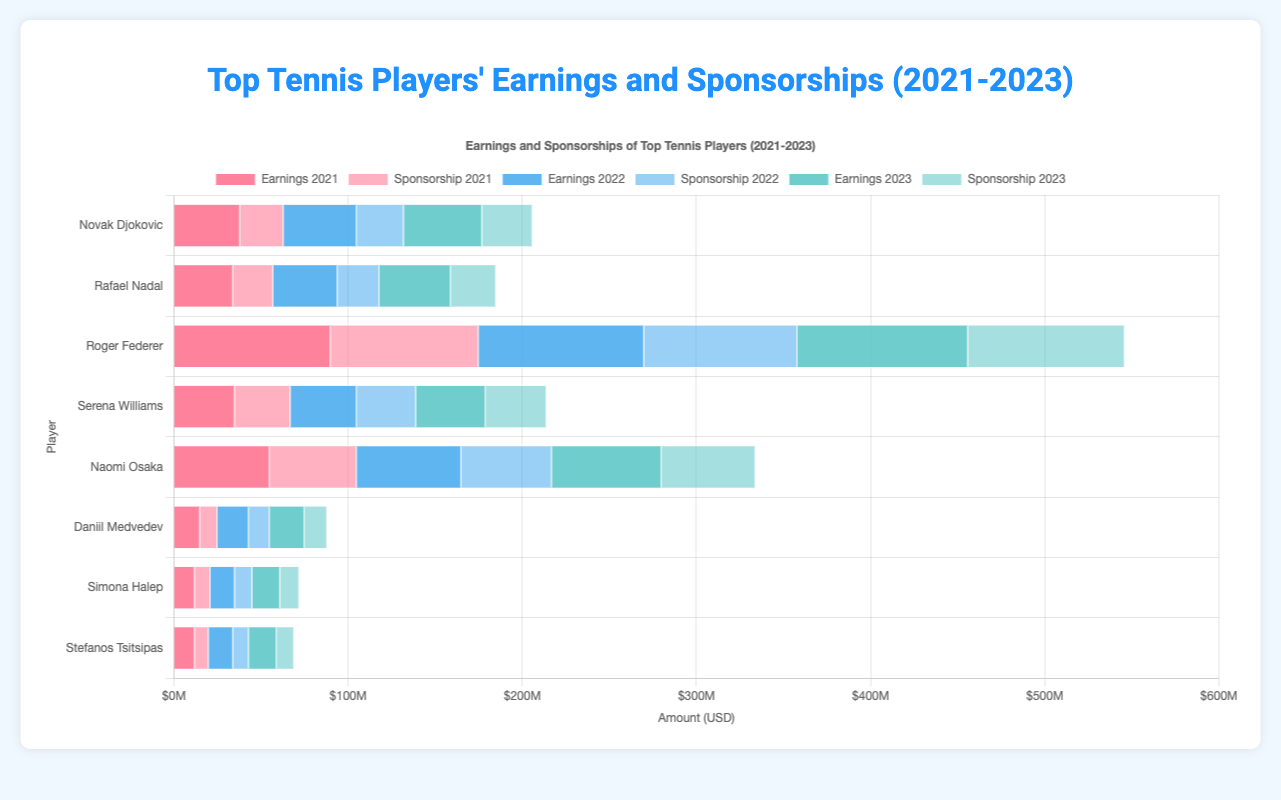Which player had the highest earnings in 2023? By looking at the chart, find the tallest bar for earnings in the year 2023. Federer’s earnings bar for 2023 is the highest.
Answer: Roger Federer What was the combined earnings and sponsorship for Naomi Osaka in 2022? Find Naomi Osaka’s earnings and sponsorship bars for 2022 and sum them up. Earnings are $60M and sponsorship is $52M. Combined amount is $60M + $52M = $112M.
Answer: $112M Between Djokovic and Nadal, who had higher total earnings and sponsorship in 2021? Compare the sum of both players' earnings and sponsorship in the year 2021. Sum for Djokovic (earnings $38M + sponsorship $25M = $63M) and for Nadal (earnings $34M + sponsorship $23M = $57M). $63M is greater than $57M, so Djokovic had higher total earnings and sponsorship.
Answer: Novak Djokovic How much did Serena Williams’ earnings increase from 2021 to 2023? Subtract Serena Williams' earnings in 2021 from her earnings in 2023. Earnings in 2023 is $40M and in 2021 it is $35M. The increase is $40M - $35M = $5M.
Answer: $5M Whose sponsorship amount in 2023 was higher: Simona Halep or Daniil Medvedev? Compare the sponsorship bars of Simona Halep and Daniil Medvedev for 2023. Halep’s sponsorship is $11M, and Medvedev’s is $13M. $13M is greater than $11M.
Answer: Daniil Medvedev Which female player had the highest sponsorship in 2022? Look at the sponsorship bars for all female players for the year 2022. Naomi Osaka’s bar is the highest among female players for sponsorship in 2022.
Answer: Naomi Osaka What is the average earnings for Rafael Nadal over the three years? Add Rafael Nadal's earnings for 2021, 2022, and 2023, and then divide by 3. ($34M + $37M + $41M) / 3 = $112M / 3 ≈ $37.33M.
Answer: $37.33M Compare Federer’s sponsorship in 2021 and 2023. Did it increase, decrease, or stay the same? Look at Federer’s sponsorship bars for 2021 and 2023 and compare their heights. Sponsorship in 2021 is $85M and in 2023 is $90M. Sponsorship increased.
Answer: Increased 